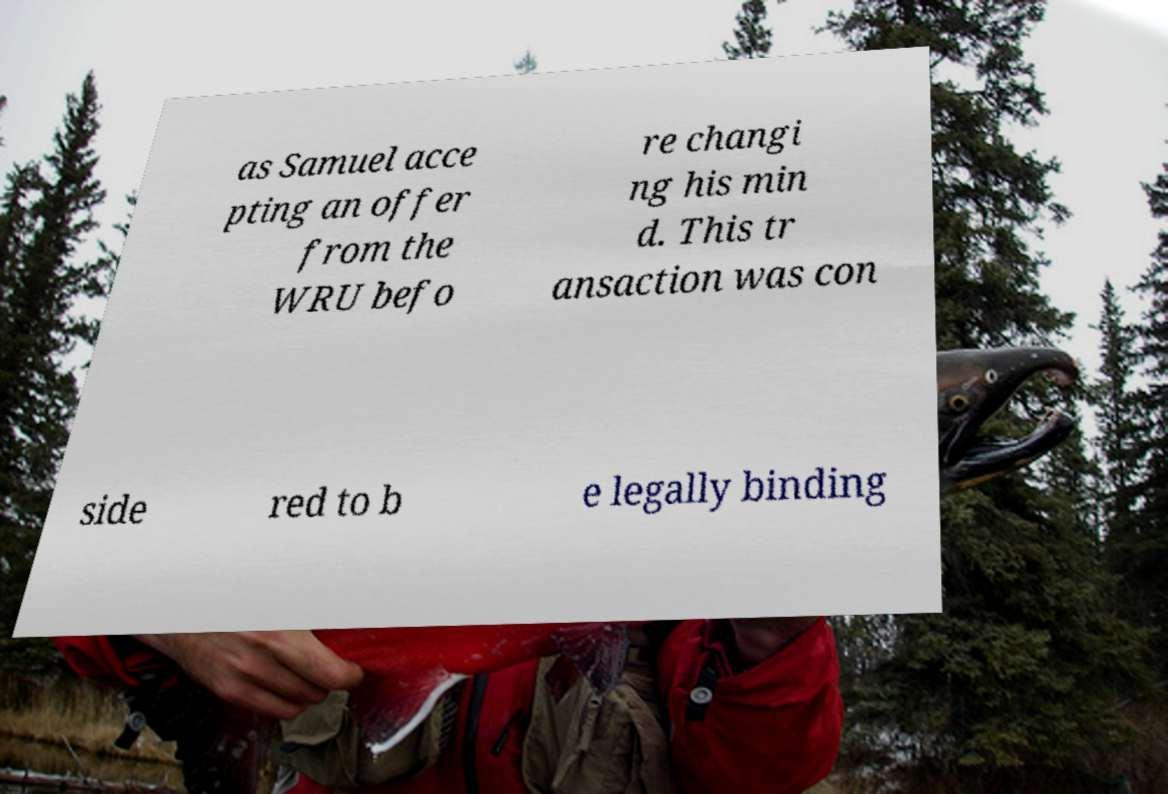There's text embedded in this image that I need extracted. Can you transcribe it verbatim? as Samuel acce pting an offer from the WRU befo re changi ng his min d. This tr ansaction was con side red to b e legally binding 